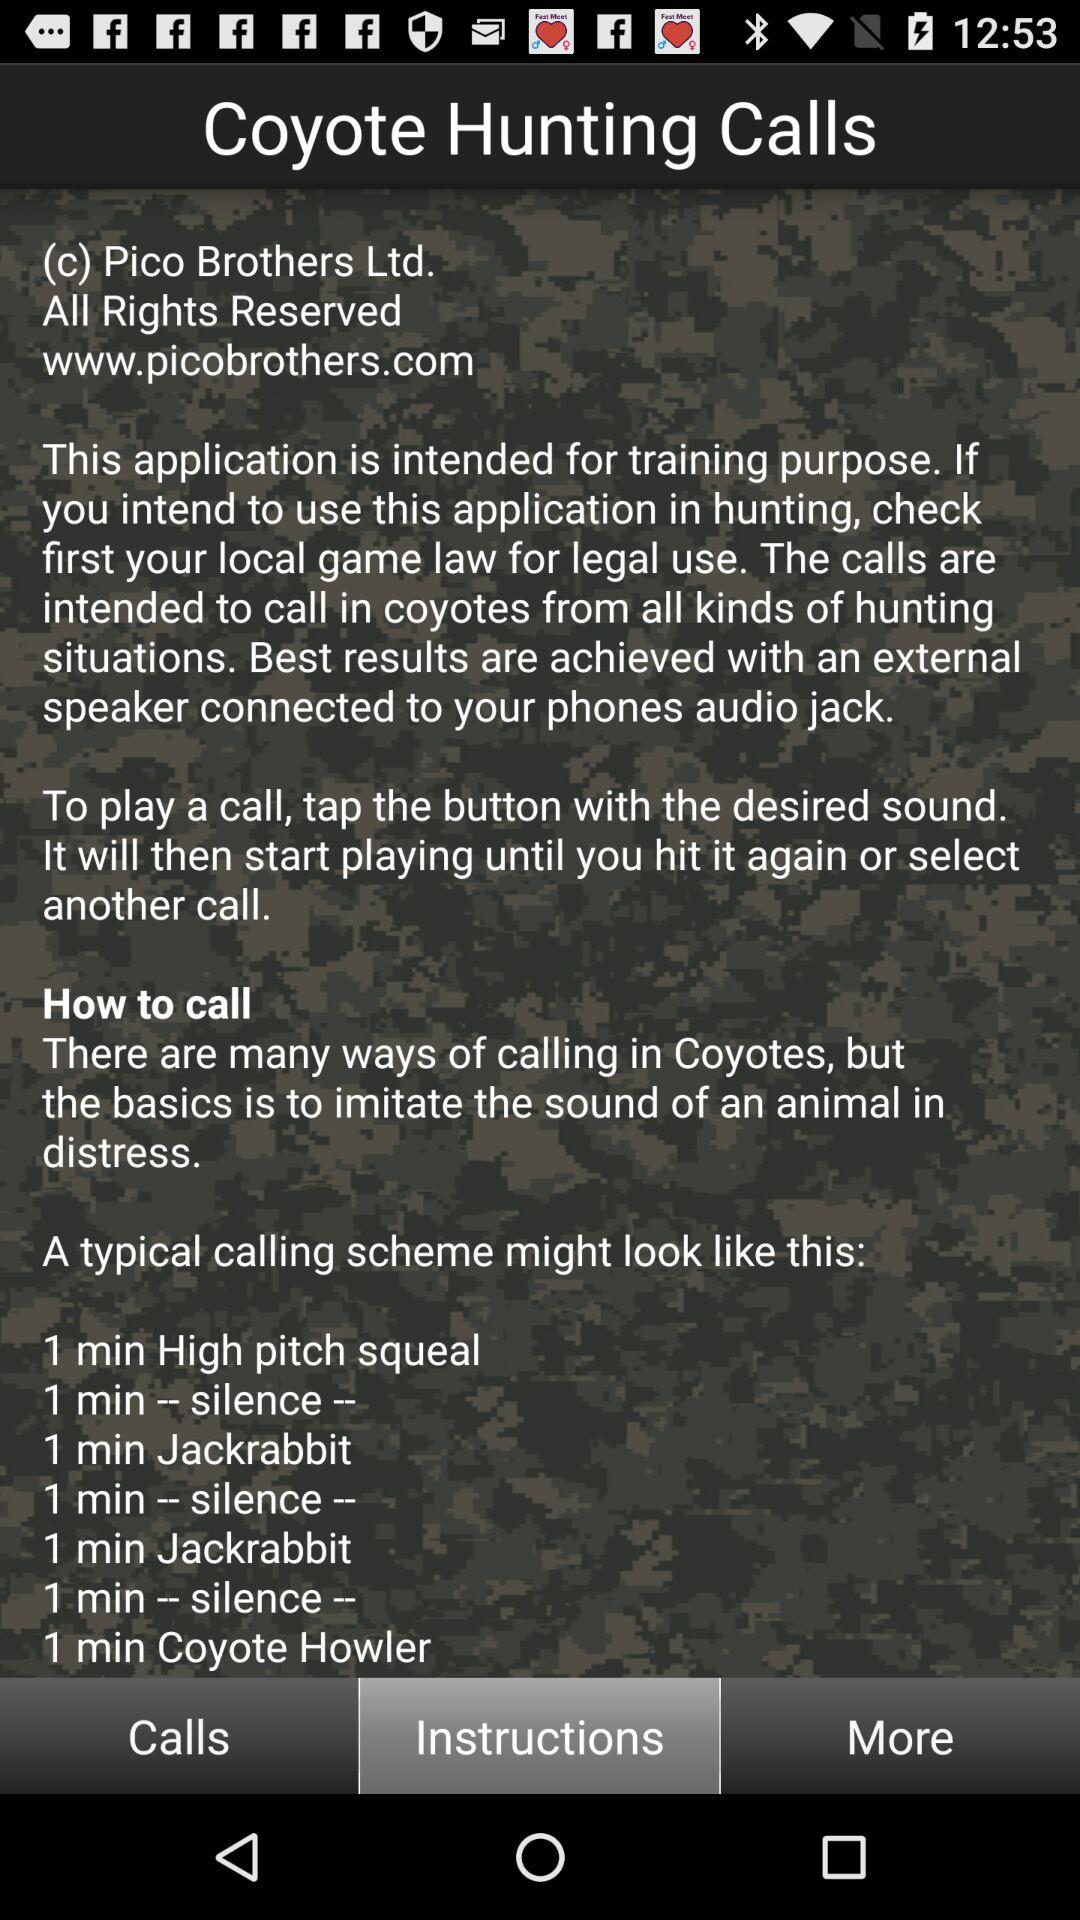How many times does the text "silence" appear in the instructions?
Answer the question using a single word or phrase. 3 